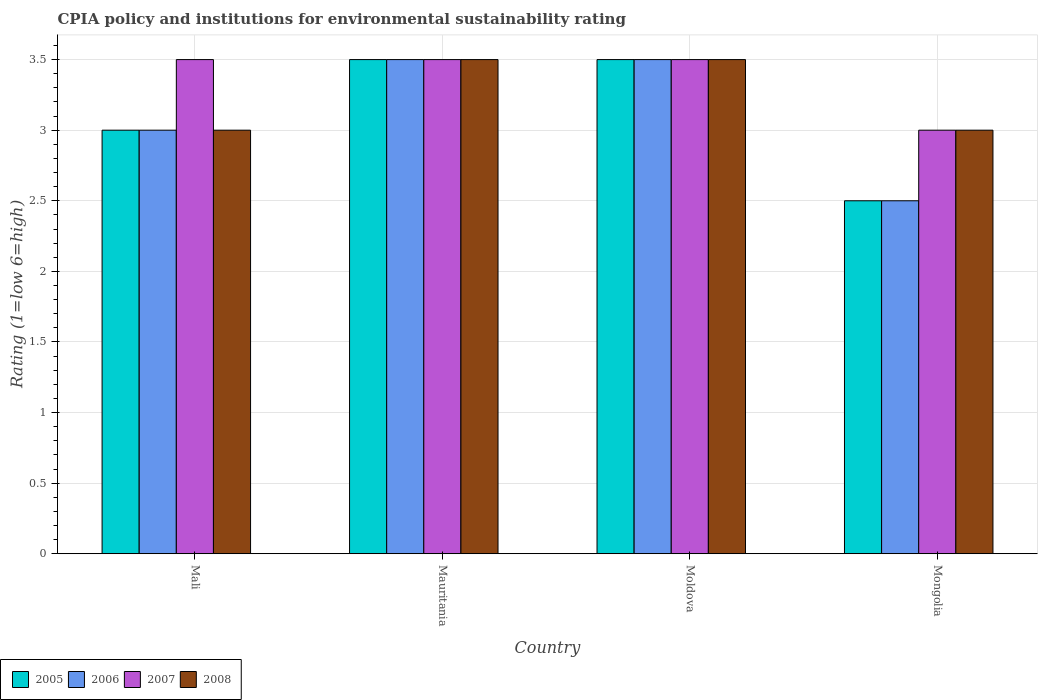How many different coloured bars are there?
Make the answer very short. 4. Are the number of bars on each tick of the X-axis equal?
Your answer should be compact. Yes. How many bars are there on the 1st tick from the left?
Offer a terse response. 4. How many bars are there on the 2nd tick from the right?
Make the answer very short. 4. What is the label of the 2nd group of bars from the left?
Your answer should be very brief. Mauritania. Across all countries, what is the maximum CPIA rating in 2006?
Provide a short and direct response. 3.5. Across all countries, what is the minimum CPIA rating in 2007?
Give a very brief answer. 3. In which country was the CPIA rating in 2008 maximum?
Provide a short and direct response. Mauritania. In which country was the CPIA rating in 2006 minimum?
Your response must be concise. Mongolia. What is the total CPIA rating in 2006 in the graph?
Your answer should be compact. 12.5. What is the difference between the CPIA rating in 2005 in Mali and that in Mauritania?
Your response must be concise. -0.5. What is the difference between the CPIA rating in 2005 in Moldova and the CPIA rating in 2007 in Mongolia?
Your answer should be very brief. 0.5. What is the average CPIA rating in 2006 per country?
Provide a succinct answer. 3.12. What is the ratio of the CPIA rating in 2007 in Mauritania to that in Mongolia?
Keep it short and to the point. 1.17. Is the difference between the CPIA rating in 2007 in Mali and Moldova greater than the difference between the CPIA rating in 2006 in Mali and Moldova?
Your answer should be compact. Yes. What is the difference between the highest and the second highest CPIA rating in 2006?
Provide a succinct answer. -0.5. What does the 2nd bar from the right in Mali represents?
Offer a very short reply. 2007. Does the graph contain grids?
Ensure brevity in your answer.  Yes. Where does the legend appear in the graph?
Provide a succinct answer. Bottom left. How many legend labels are there?
Provide a short and direct response. 4. How are the legend labels stacked?
Keep it short and to the point. Horizontal. What is the title of the graph?
Provide a short and direct response. CPIA policy and institutions for environmental sustainability rating. What is the Rating (1=low 6=high) of 2005 in Mali?
Keep it short and to the point. 3. What is the Rating (1=low 6=high) in 2007 in Mali?
Offer a terse response. 3.5. What is the Rating (1=low 6=high) of 2008 in Mali?
Offer a very short reply. 3. What is the Rating (1=low 6=high) of 2006 in Mauritania?
Your response must be concise. 3.5. What is the Rating (1=low 6=high) of 2007 in Mauritania?
Your response must be concise. 3.5. What is the Rating (1=low 6=high) of 2008 in Mauritania?
Your answer should be compact. 3.5. What is the Rating (1=low 6=high) in 2006 in Moldova?
Give a very brief answer. 3.5. What is the Rating (1=low 6=high) in 2007 in Moldova?
Offer a terse response. 3.5. What is the Rating (1=low 6=high) of 2008 in Moldova?
Your answer should be compact. 3.5. What is the Rating (1=low 6=high) in 2005 in Mongolia?
Offer a very short reply. 2.5. What is the Rating (1=low 6=high) of 2006 in Mongolia?
Your answer should be very brief. 2.5. What is the Rating (1=low 6=high) of 2007 in Mongolia?
Give a very brief answer. 3. What is the Rating (1=low 6=high) of 2008 in Mongolia?
Provide a succinct answer. 3. Across all countries, what is the maximum Rating (1=low 6=high) of 2005?
Provide a short and direct response. 3.5. Across all countries, what is the maximum Rating (1=low 6=high) of 2008?
Provide a short and direct response. 3.5. Across all countries, what is the minimum Rating (1=low 6=high) of 2005?
Offer a very short reply. 2.5. Across all countries, what is the minimum Rating (1=low 6=high) of 2008?
Offer a terse response. 3. What is the total Rating (1=low 6=high) of 2008 in the graph?
Offer a very short reply. 13. What is the difference between the Rating (1=low 6=high) of 2006 in Mali and that in Mauritania?
Offer a terse response. -0.5. What is the difference between the Rating (1=low 6=high) of 2007 in Mali and that in Mauritania?
Your answer should be compact. 0. What is the difference between the Rating (1=low 6=high) of 2008 in Mali and that in Mauritania?
Ensure brevity in your answer.  -0.5. What is the difference between the Rating (1=low 6=high) of 2005 in Mali and that in Mongolia?
Your answer should be very brief. 0.5. What is the difference between the Rating (1=low 6=high) of 2006 in Mali and that in Mongolia?
Keep it short and to the point. 0.5. What is the difference between the Rating (1=low 6=high) of 2005 in Mauritania and that in Moldova?
Ensure brevity in your answer.  0. What is the difference between the Rating (1=low 6=high) of 2008 in Mauritania and that in Moldova?
Give a very brief answer. 0. What is the difference between the Rating (1=low 6=high) in 2008 in Mauritania and that in Mongolia?
Offer a terse response. 0.5. What is the difference between the Rating (1=low 6=high) in 2007 in Moldova and that in Mongolia?
Your answer should be very brief. 0.5. What is the difference between the Rating (1=low 6=high) in 2005 in Mali and the Rating (1=low 6=high) in 2006 in Mauritania?
Your response must be concise. -0.5. What is the difference between the Rating (1=low 6=high) of 2005 in Mali and the Rating (1=low 6=high) of 2007 in Mauritania?
Provide a succinct answer. -0.5. What is the difference between the Rating (1=low 6=high) in 2005 in Mali and the Rating (1=low 6=high) in 2008 in Mauritania?
Make the answer very short. -0.5. What is the difference between the Rating (1=low 6=high) in 2006 in Mali and the Rating (1=low 6=high) in 2008 in Mauritania?
Your response must be concise. -0.5. What is the difference between the Rating (1=low 6=high) in 2007 in Mali and the Rating (1=low 6=high) in 2008 in Mauritania?
Offer a terse response. 0. What is the difference between the Rating (1=low 6=high) of 2006 in Mali and the Rating (1=low 6=high) of 2008 in Moldova?
Give a very brief answer. -0.5. What is the difference between the Rating (1=low 6=high) in 2007 in Mali and the Rating (1=low 6=high) in 2008 in Moldova?
Provide a succinct answer. 0. What is the difference between the Rating (1=low 6=high) in 2005 in Mali and the Rating (1=low 6=high) in 2006 in Mongolia?
Give a very brief answer. 0.5. What is the difference between the Rating (1=low 6=high) in 2005 in Mali and the Rating (1=low 6=high) in 2007 in Mongolia?
Your response must be concise. 0. What is the difference between the Rating (1=low 6=high) of 2006 in Mali and the Rating (1=low 6=high) of 2007 in Mongolia?
Provide a succinct answer. 0. What is the difference between the Rating (1=low 6=high) in 2005 in Mauritania and the Rating (1=low 6=high) in 2006 in Moldova?
Your response must be concise. 0. What is the difference between the Rating (1=low 6=high) of 2005 in Mauritania and the Rating (1=low 6=high) of 2007 in Moldova?
Give a very brief answer. 0. What is the difference between the Rating (1=low 6=high) of 2005 in Mauritania and the Rating (1=low 6=high) of 2008 in Moldova?
Provide a succinct answer. 0. What is the difference between the Rating (1=low 6=high) in 2006 in Mauritania and the Rating (1=low 6=high) in 2007 in Moldova?
Your answer should be compact. 0. What is the difference between the Rating (1=low 6=high) of 2007 in Mauritania and the Rating (1=low 6=high) of 2008 in Moldova?
Provide a short and direct response. 0. What is the difference between the Rating (1=low 6=high) of 2005 in Mauritania and the Rating (1=low 6=high) of 2006 in Mongolia?
Provide a short and direct response. 1. What is the difference between the Rating (1=low 6=high) of 2005 in Mauritania and the Rating (1=low 6=high) of 2007 in Mongolia?
Give a very brief answer. 0.5. What is the difference between the Rating (1=low 6=high) of 2005 in Mauritania and the Rating (1=low 6=high) of 2008 in Mongolia?
Provide a succinct answer. 0.5. What is the difference between the Rating (1=low 6=high) of 2006 in Mauritania and the Rating (1=low 6=high) of 2008 in Mongolia?
Give a very brief answer. 0.5. What is the difference between the Rating (1=low 6=high) of 2005 in Moldova and the Rating (1=low 6=high) of 2006 in Mongolia?
Your answer should be compact. 1. What is the difference between the Rating (1=low 6=high) of 2005 in Moldova and the Rating (1=low 6=high) of 2008 in Mongolia?
Make the answer very short. 0.5. What is the difference between the Rating (1=low 6=high) in 2006 in Moldova and the Rating (1=low 6=high) in 2007 in Mongolia?
Keep it short and to the point. 0.5. What is the difference between the Rating (1=low 6=high) in 2007 in Moldova and the Rating (1=low 6=high) in 2008 in Mongolia?
Your answer should be compact. 0.5. What is the average Rating (1=low 6=high) in 2005 per country?
Keep it short and to the point. 3.12. What is the average Rating (1=low 6=high) in 2006 per country?
Your answer should be compact. 3.12. What is the average Rating (1=low 6=high) in 2007 per country?
Offer a terse response. 3.38. What is the average Rating (1=low 6=high) in 2008 per country?
Your answer should be compact. 3.25. What is the difference between the Rating (1=low 6=high) in 2005 and Rating (1=low 6=high) in 2007 in Mali?
Your answer should be very brief. -0.5. What is the difference between the Rating (1=low 6=high) in 2006 and Rating (1=low 6=high) in 2007 in Mali?
Your answer should be compact. -0.5. What is the difference between the Rating (1=low 6=high) of 2007 and Rating (1=low 6=high) of 2008 in Mali?
Provide a succinct answer. 0.5. What is the difference between the Rating (1=low 6=high) in 2005 and Rating (1=low 6=high) in 2006 in Mauritania?
Provide a short and direct response. 0. What is the difference between the Rating (1=low 6=high) in 2005 and Rating (1=low 6=high) in 2007 in Mauritania?
Ensure brevity in your answer.  0. What is the difference between the Rating (1=low 6=high) in 2006 and Rating (1=low 6=high) in 2008 in Mauritania?
Your answer should be compact. 0. What is the difference between the Rating (1=low 6=high) of 2005 and Rating (1=low 6=high) of 2006 in Moldova?
Your answer should be very brief. 0. What is the difference between the Rating (1=low 6=high) of 2005 and Rating (1=low 6=high) of 2007 in Moldova?
Provide a short and direct response. 0. What is the difference between the Rating (1=low 6=high) of 2005 and Rating (1=low 6=high) of 2008 in Moldova?
Keep it short and to the point. 0. What is the difference between the Rating (1=low 6=high) of 2006 and Rating (1=low 6=high) of 2007 in Moldova?
Make the answer very short. 0. What is the difference between the Rating (1=low 6=high) in 2007 and Rating (1=low 6=high) in 2008 in Moldova?
Keep it short and to the point. 0. What is the difference between the Rating (1=low 6=high) in 2005 and Rating (1=low 6=high) in 2007 in Mongolia?
Ensure brevity in your answer.  -0.5. What is the ratio of the Rating (1=low 6=high) in 2005 in Mali to that in Mauritania?
Make the answer very short. 0.86. What is the ratio of the Rating (1=low 6=high) of 2006 in Mali to that in Mauritania?
Your answer should be compact. 0.86. What is the ratio of the Rating (1=low 6=high) of 2008 in Mali to that in Mauritania?
Make the answer very short. 0.86. What is the ratio of the Rating (1=low 6=high) of 2006 in Mali to that in Moldova?
Keep it short and to the point. 0.86. What is the ratio of the Rating (1=low 6=high) in 2007 in Mali to that in Moldova?
Your answer should be very brief. 1. What is the ratio of the Rating (1=low 6=high) in 2008 in Mali to that in Moldova?
Ensure brevity in your answer.  0.86. What is the ratio of the Rating (1=low 6=high) in 2006 in Mali to that in Mongolia?
Your answer should be very brief. 1.2. What is the ratio of the Rating (1=low 6=high) of 2008 in Mali to that in Mongolia?
Offer a very short reply. 1. What is the ratio of the Rating (1=low 6=high) in 2005 in Mauritania to that in Moldova?
Ensure brevity in your answer.  1. What is the ratio of the Rating (1=low 6=high) of 2006 in Mauritania to that in Moldova?
Make the answer very short. 1. What is the ratio of the Rating (1=low 6=high) of 2006 in Mauritania to that in Mongolia?
Give a very brief answer. 1.4. What is the ratio of the Rating (1=low 6=high) of 2007 in Mauritania to that in Mongolia?
Your response must be concise. 1.17. What is the ratio of the Rating (1=low 6=high) in 2005 in Moldova to that in Mongolia?
Your response must be concise. 1.4. What is the difference between the highest and the second highest Rating (1=low 6=high) of 2005?
Provide a succinct answer. 0. What is the difference between the highest and the second highest Rating (1=low 6=high) of 2006?
Make the answer very short. 0. What is the difference between the highest and the second highest Rating (1=low 6=high) in 2007?
Your answer should be very brief. 0. What is the difference between the highest and the second highest Rating (1=low 6=high) of 2008?
Your answer should be very brief. 0. What is the difference between the highest and the lowest Rating (1=low 6=high) of 2005?
Your response must be concise. 1. What is the difference between the highest and the lowest Rating (1=low 6=high) in 2006?
Provide a short and direct response. 1. What is the difference between the highest and the lowest Rating (1=low 6=high) in 2007?
Offer a very short reply. 0.5. 